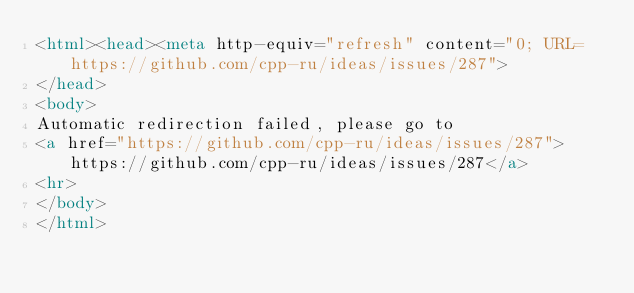<code> <loc_0><loc_0><loc_500><loc_500><_HTML_><html><head><meta http-equiv="refresh" content="0; URL=https://github.com/cpp-ru/ideas/issues/287">
</head>
<body>
Automatic redirection failed, please go to
<a href="https://github.com/cpp-ru/ideas/issues/287">https://github.com/cpp-ru/ideas/issues/287</a>
<hr>
</body>
</html>
</code> 